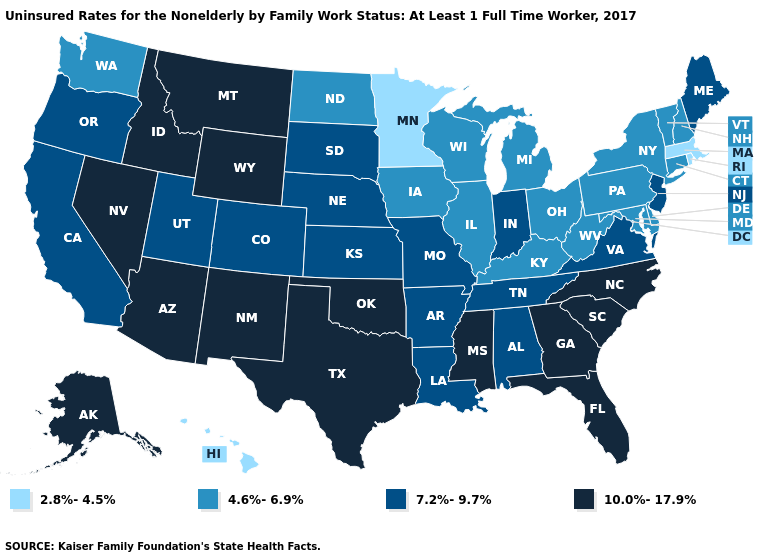What is the highest value in the West ?
Keep it brief. 10.0%-17.9%. Is the legend a continuous bar?
Give a very brief answer. No. Does California have the same value as Utah?
Keep it brief. Yes. Name the states that have a value in the range 10.0%-17.9%?
Concise answer only. Alaska, Arizona, Florida, Georgia, Idaho, Mississippi, Montana, Nevada, New Mexico, North Carolina, Oklahoma, South Carolina, Texas, Wyoming. Does Massachusetts have the same value as Hawaii?
Keep it brief. Yes. Name the states that have a value in the range 10.0%-17.9%?
Quick response, please. Alaska, Arizona, Florida, Georgia, Idaho, Mississippi, Montana, Nevada, New Mexico, North Carolina, Oklahoma, South Carolina, Texas, Wyoming. What is the value of Alaska?
Concise answer only. 10.0%-17.9%. What is the lowest value in states that border Iowa?
Write a very short answer. 2.8%-4.5%. Does Minnesota have a lower value than Hawaii?
Be succinct. No. What is the lowest value in the USA?
Be succinct. 2.8%-4.5%. Which states have the highest value in the USA?
Answer briefly. Alaska, Arizona, Florida, Georgia, Idaho, Mississippi, Montana, Nevada, New Mexico, North Carolina, Oklahoma, South Carolina, Texas, Wyoming. Name the states that have a value in the range 4.6%-6.9%?
Answer briefly. Connecticut, Delaware, Illinois, Iowa, Kentucky, Maryland, Michigan, New Hampshire, New York, North Dakota, Ohio, Pennsylvania, Vermont, Washington, West Virginia, Wisconsin. Does the map have missing data?
Give a very brief answer. No. How many symbols are there in the legend?
Give a very brief answer. 4. How many symbols are there in the legend?
Keep it brief. 4. 